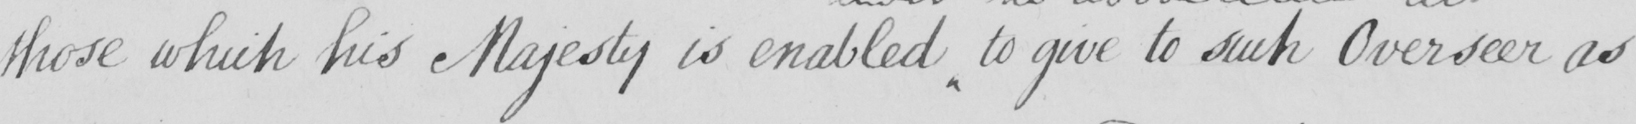What text is written in this handwritten line? those which his Majesty is enabled to give to such Overseer as 